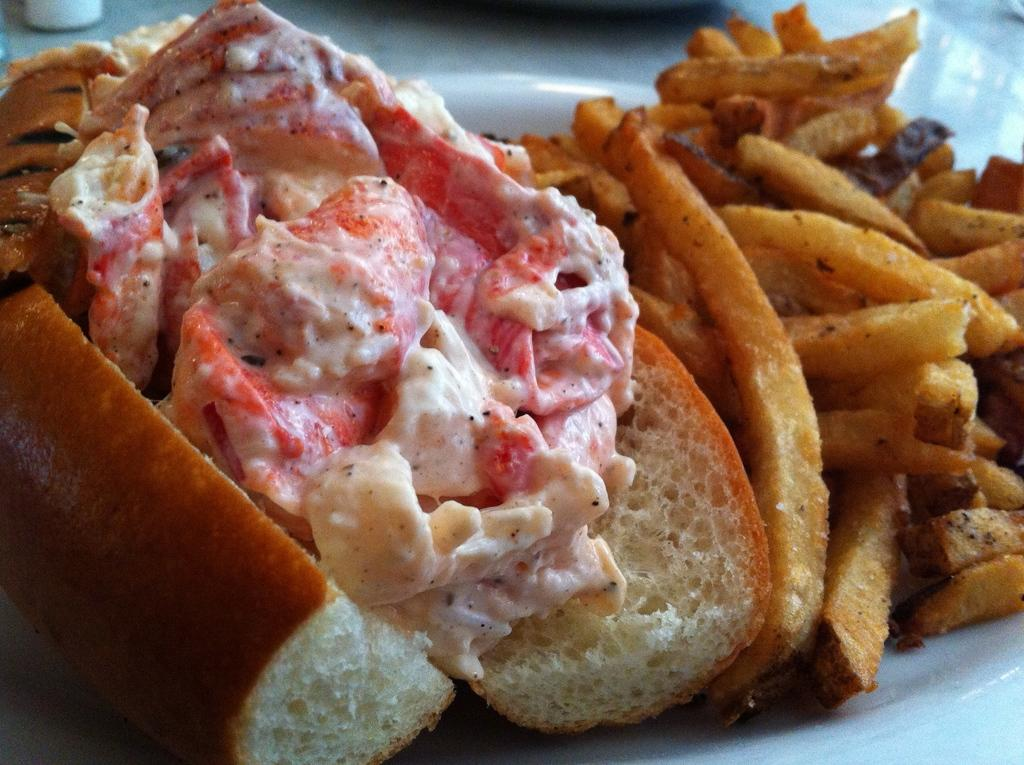What type of food is on the plate in the image? There is a burger on a plate in the image. Are there any other types of food on the plate? Yes, there are french fries on a plate in the image. How many houses can be seen in the image? There are no houses present in the image; it features a burger and french fries on a plate. What type of sail is visible in the image? There is no sail present in the image; it features a burger and french fries on a plate. 